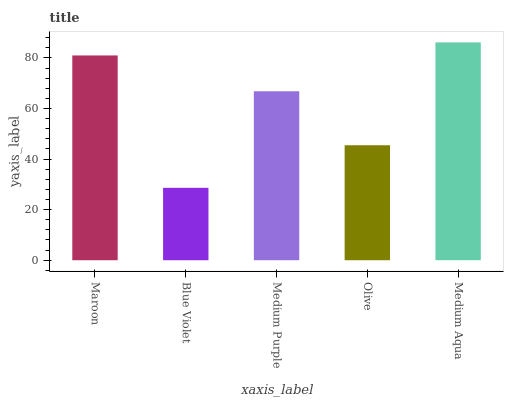Is Blue Violet the minimum?
Answer yes or no. Yes. Is Medium Aqua the maximum?
Answer yes or no. Yes. Is Medium Purple the minimum?
Answer yes or no. No. Is Medium Purple the maximum?
Answer yes or no. No. Is Medium Purple greater than Blue Violet?
Answer yes or no. Yes. Is Blue Violet less than Medium Purple?
Answer yes or no. Yes. Is Blue Violet greater than Medium Purple?
Answer yes or no. No. Is Medium Purple less than Blue Violet?
Answer yes or no. No. Is Medium Purple the high median?
Answer yes or no. Yes. Is Medium Purple the low median?
Answer yes or no. Yes. Is Blue Violet the high median?
Answer yes or no. No. Is Medium Aqua the low median?
Answer yes or no. No. 